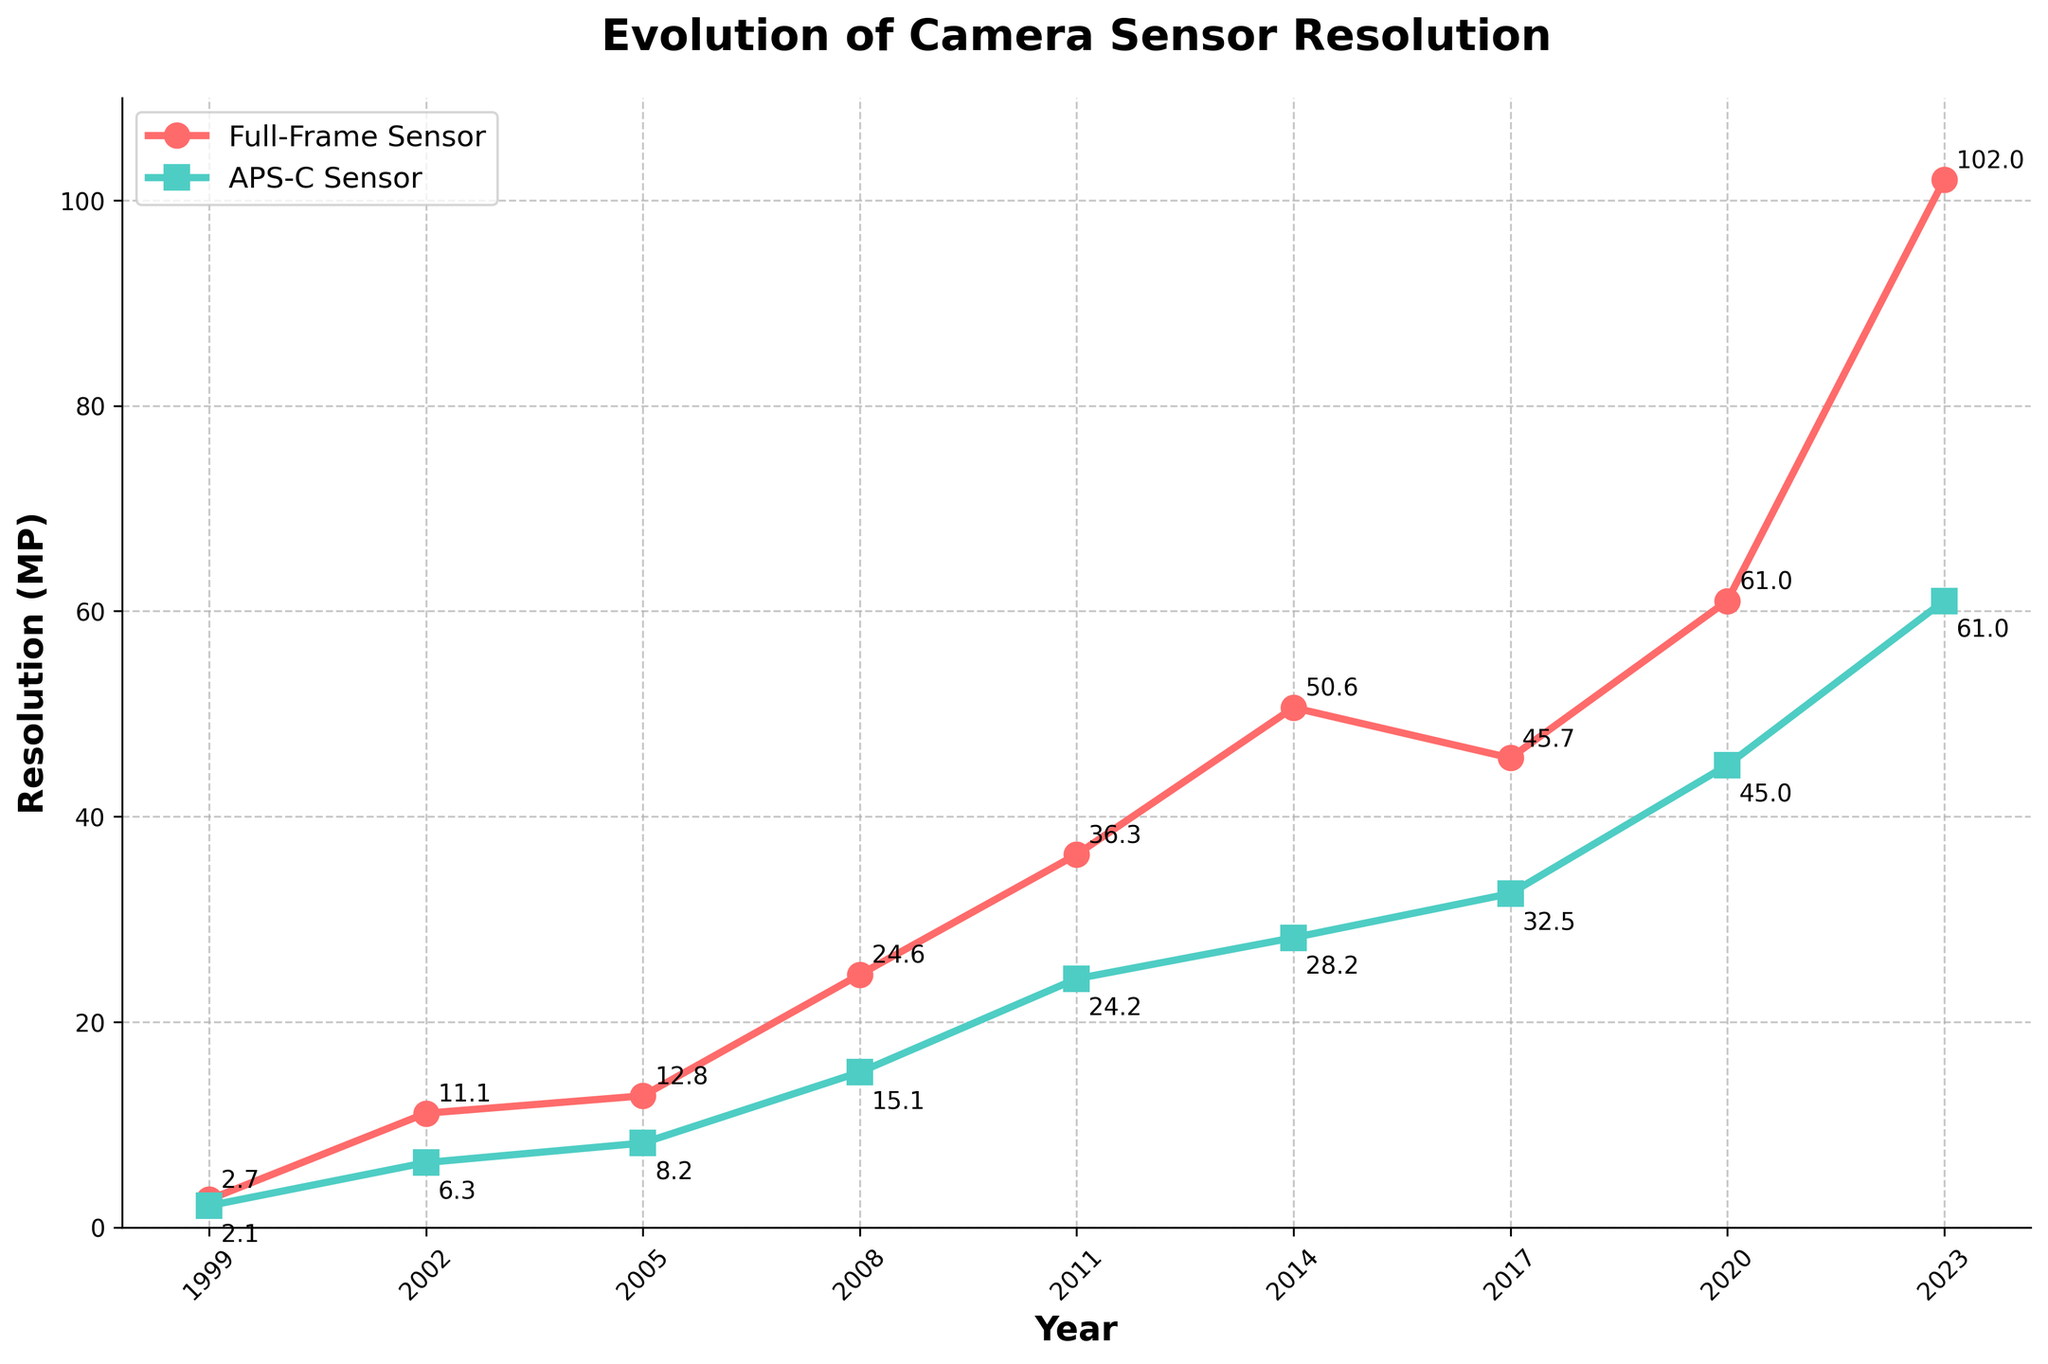What is the resolution difference between Full-Frame and APS-C sensors in 2023? The value for Full-Frame resolution in 2023 is 102.0 MP and for APS-C resolution is 61.0 MP. The difference can be calculated as 102.0 MP - 61.0 MP = 41.0 MP.
Answer: 41.0 MP How has the Full-Frame sensor resolution changed from 1999 to 2023? In 1999, the Full-Frame resolution was 2.7 MP and in 2023 it increased to 102.0 MP. The change can be calculated as 102.0 MP - 2.7 MP = 99.3 MP.
Answer: 99.3 MP Which year saw the biggest increase in APS-C sensor resolution? By looking at the APS-C sensor resolution changes year by year, the biggest increase occurred between 2017 (32.5 MP) and 2020 (45.0 MP). The increase is 45.0 MP - 32.5 MP = 12.5 MP.
Answer: 2017 to 2020 What was the ratio of Full-Frame sensor resolution to APS-C sensor resolution in 2011? The Full-Frame resolution in 2011 was 36.3 MP and the APS-C resolution was 24.2 MP. The ratio can be calculated as 36.3 / 24.2 ≈ 1.50.
Answer: 1.50 Between which two consecutive years did the Full-Frame sensor resolution more than double? We need to compare the Full-Frame resolution between consecutive years and check if it more than doubled. Between 2002 (11.1 MP) and 2008 (24.6 MP), it increased by 24.6 / 11.1 ≈ 2.22 times, which is more than double.
Answer: 2002 to 2008 In which year does the Full-Frame sensor resolution first exceed 50 MP? By checking the Full-Frame sensor resolution values year by year, it first exceeds 50 MP in 2014 with a value of 50.6 MP.
Answer: 2014 How much more did the Full-Frame sensor resolution increase compared to APS-C from 2008 to 2023? The Full-Frame resolution increased by 102.0 MP - 24.6 MP = 77.4 MP, and the APS-C resolution increased by 61.0 MP - 15.1 MP = 45.9 MP. The difference is 77.4 MP - 45.9 MP = 31.5 MP.
Answer: 31.5 MP What is the average APS-C sensor resolution across all years? The APS-C sensor resolutions are 2.1, 6.3, 8.2, 15.1, 24.2, 28.2, 32.5, 45.0, and 61.0 MP. The sum is 222.6 MP. There are 9 values, so the average is 222.6 MP / 9 ≈ 24.7 MP.
Answer: 24.7 MP Which sensor type has shown a more consistent increase in resolution over the years? By examining the trend lines, it is clearly visible that both Full-Frame and APS-C sensor resolutions have increased over the years. However, the Full-Frame sensor shows a more consistent and significant increase compared to APS-C, which shows more variability in its increments.
Answer: Full-Frame In what year did both Full-Frame and APS-C sensor resolutions experience simultaneous significant increases? Looking at the plotted lines, both sensor resolutions appear to have a simultaneous significant increase between 2002 and 2008. Full-Frame increased from 11.1 to 24.6 MP, and APS-C from 6.3 to 15.1 MP.
Answer: 2002 to 2008 